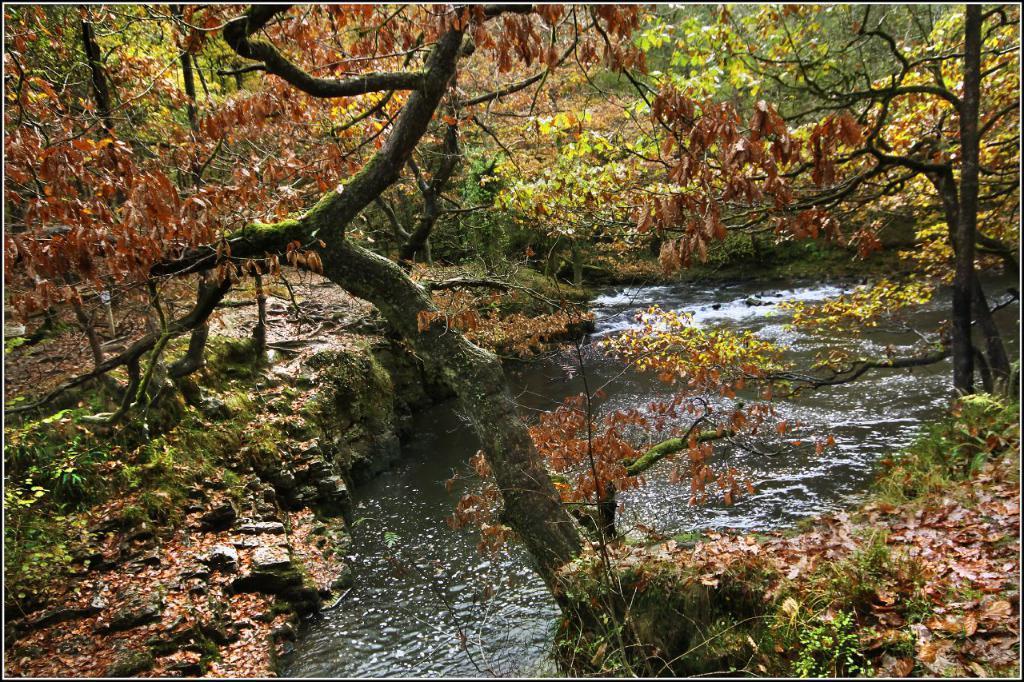Could you give a brief overview of what you see in this image? Here in this picture we can see water flowing over a place and we can see plants and trees present all over the place over there. 